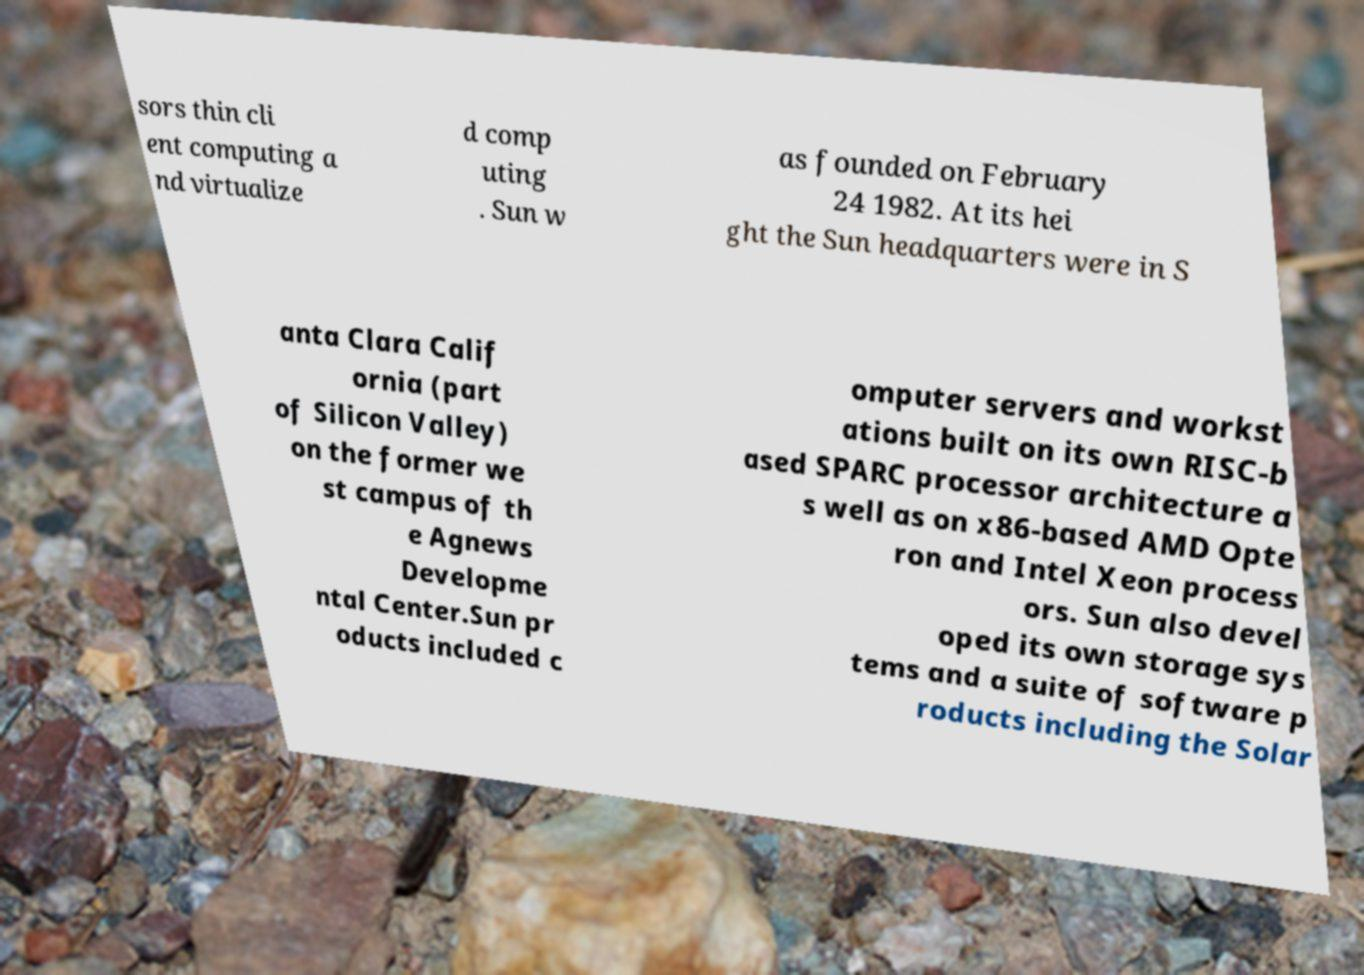What messages or text are displayed in this image? I need them in a readable, typed format. sors thin cli ent computing a nd virtualize d comp uting . Sun w as founded on February 24 1982. At its hei ght the Sun headquarters were in S anta Clara Calif ornia (part of Silicon Valley) on the former we st campus of th e Agnews Developme ntal Center.Sun pr oducts included c omputer servers and workst ations built on its own RISC-b ased SPARC processor architecture a s well as on x86-based AMD Opte ron and Intel Xeon process ors. Sun also devel oped its own storage sys tems and a suite of software p roducts including the Solar 